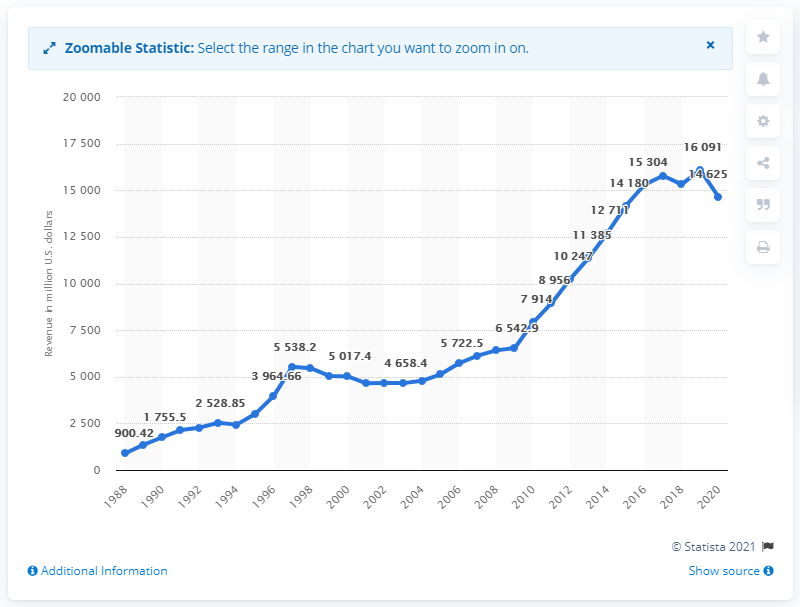Highlight a few significant elements in this photo. In 2020, Nike's revenue in the United States was approximately 14,625. 